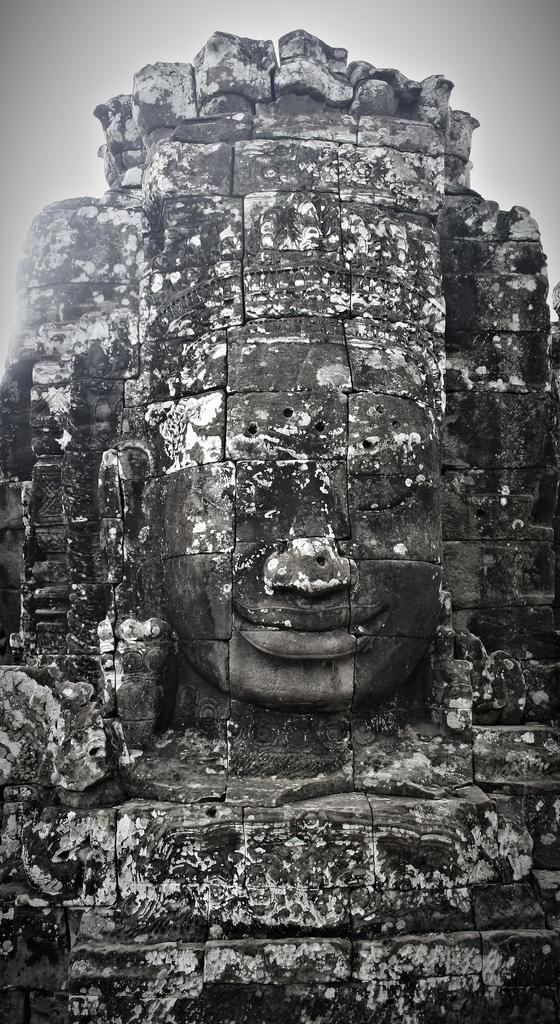What is the main subject of the image? There is a sculpture in the image. Where is the sculpture located in the image? The sculpture is in the center of the image. What type of coat is the mom wearing in the image? There is no mom or coat present in the image; it only features a sculpture in the center. 